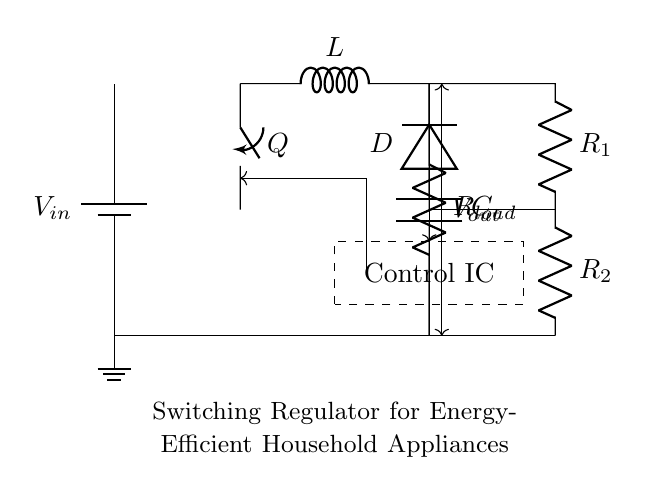What is the input voltage labeled in the circuit? The input voltage source is labeled as V_in, indicating it is the source voltage to the circuit.
Answer: V_in What component is used to store energy in this circuit? The inductor, labeled as L, is used to store energy in a magnetic field during operation.
Answer: L What does the control IC do in this regulator circuit? The control IC is responsible for regulating the output voltage by controlling the switching of the transistor Q based on feedback from the output voltage.
Answer: Control IC What is the function of the diode labeled D? The diode D allows current to flow only in one direction, ensuring that energy stored in the inductor is delivered to the load while preventing backflow during the off cycle of the switch Q.
Answer: Prevents backflow How does the feedback network affect the output voltage? The feedback network, consisting of R_1 and R_2, monitors the output voltage V_out and feeds this information back to the Control IC to adjust the switch Q for maintaining a stable output voltage.
Answer: Stabilizes output voltage Which component limits the current flowing to the load? The load resistor, labeled as R_load, limits the amount of current that flows to the connected load.
Answer: R_load What happens when the switch Q is closed? When switch Q is closed, current flows from V_in through the inductor L, causing it to store energy, and during this time, the output capacitor C charges until the switch opens again.
Answer: Stores energy 